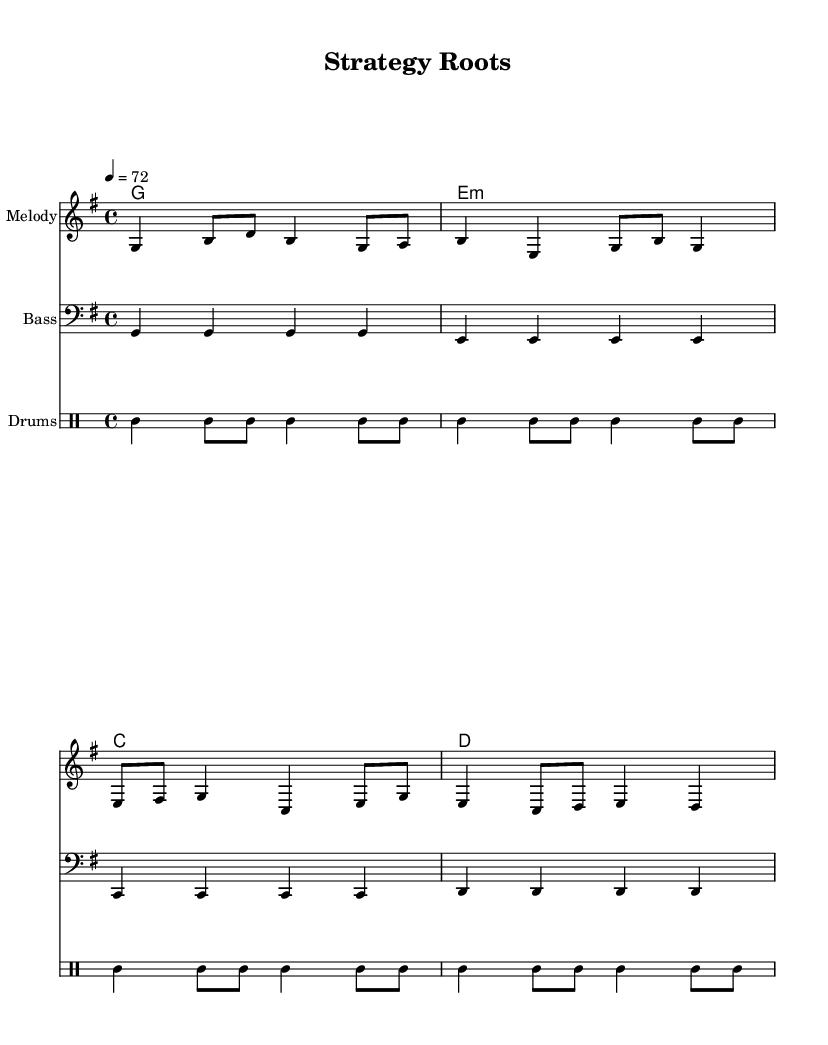What is the key signature of this music? The key signature is indicated in the global section as 'g', which is the key of G major with one sharp.
Answer: G major What is the time signature of this sheet music? The time signature is provided in the global section with the notation '4/4', meaning there are four beats per measure and the quarter note gets one beat.
Answer: 4/4 What is the tempo marking of the piece? The tempo marking is indicated in the global section as '4 = 72', which means the quarter note should be played at a rate of 72 beats per minute.
Answer: 72 How many measures are in the melody section? The melody section contains four distinct phrases, which can be counted as four measures in total when broken down into sections.
Answer: 4 What instruments are used in this score? The score includes three parts: a melody instrument, a bass, and a drum part specifically indicated with 'Drums'.
Answer: Melody, Bass, Drums What is the main chord progression used in the music? The chord progression, listed in the chordNames section, consists of G major, E minor, C major, and D major, which creates a classic reggae harmonic structure.
Answer: G, E minor, C, D Why are the drums written in a different staff? The drums are written in a separate 'DrumStaff' because they require unique notation for percussion instruments, allowing for clearer reading and playing.
Answer: Separate staff for percussion 